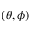<formula> <loc_0><loc_0><loc_500><loc_500>( \theta , \phi )</formula> 